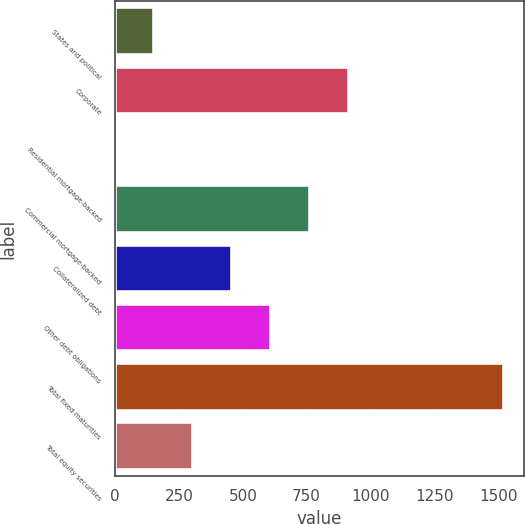Convert chart. <chart><loc_0><loc_0><loc_500><loc_500><bar_chart><fcel>States and political<fcel>Corporate<fcel>Residential mortgage-backed<fcel>Commercial mortgage-backed<fcel>Collateralized debt<fcel>Other debt obligations<fcel>Total fixed maturities<fcel>Total equity securities<nl><fcel>153.03<fcel>914.68<fcel>0.7<fcel>762.35<fcel>457.69<fcel>610.02<fcel>1524<fcel>305.36<nl></chart> 